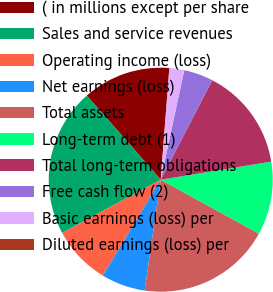Convert chart. <chart><loc_0><loc_0><loc_500><loc_500><pie_chart><fcel>( in millions except per share<fcel>Sales and service revenues<fcel>Operating income (loss)<fcel>Net earnings (loss)<fcel>Total assets<fcel>Long-term debt (1)<fcel>Total long-term obligations<fcel>Free cash flow (2)<fcel>Basic earnings (loss) per<fcel>Diluted earnings (loss) per<nl><fcel>12.69%<fcel>21.41%<fcel>8.47%<fcel>6.35%<fcel>19.3%<fcel>10.58%<fcel>14.81%<fcel>4.24%<fcel>2.13%<fcel>0.02%<nl></chart> 